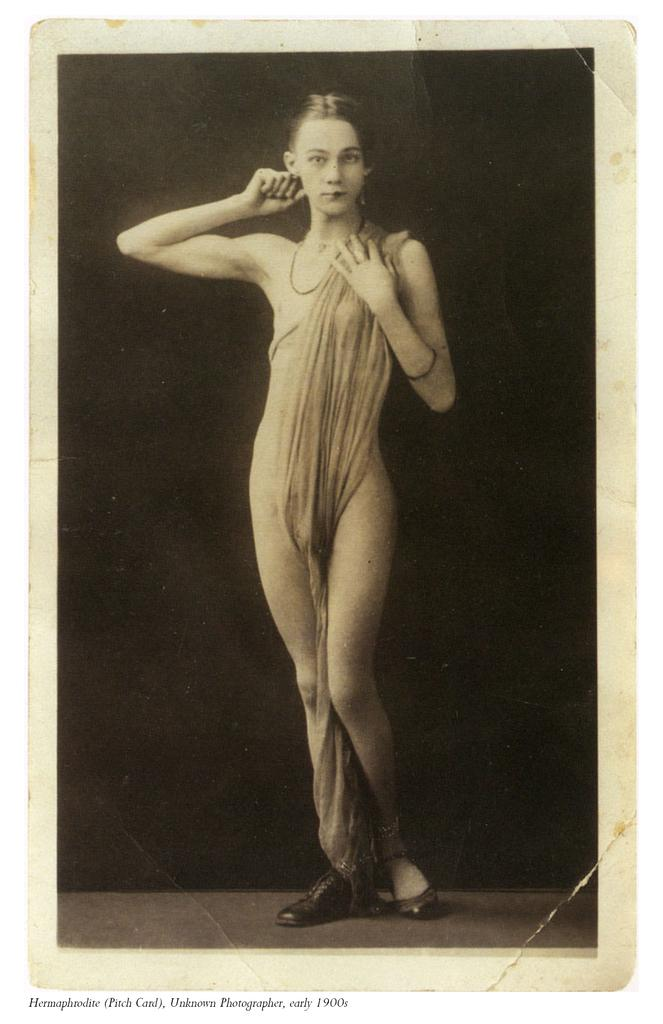Who is the main subject in the image? There is a girl in the center of the image. Can you describe the girl's position in the image? The girl is in the center of the image. What is the mass of the face that the girl is holding in the image? There is no face present in the image, and therefore no mass can be determined. 